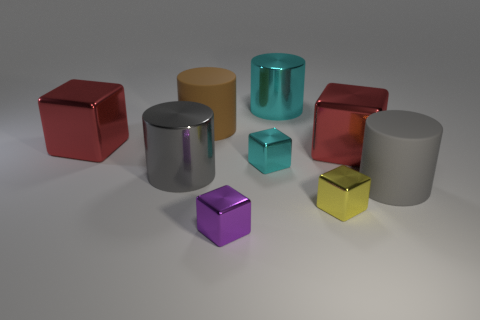Subtract all red cubes. How many gray cylinders are left? 2 Subtract 2 blocks. How many blocks are left? 3 Subtract all yellow blocks. How many blocks are left? 4 Subtract all tiny purple metal cubes. How many cubes are left? 4 Subtract all yellow cylinders. Subtract all blue blocks. How many cylinders are left? 4 Subtract all cylinders. How many objects are left? 5 Add 3 gray metal cylinders. How many gray metal cylinders are left? 4 Add 2 large red balls. How many large red balls exist? 2 Subtract 1 purple blocks. How many objects are left? 8 Subtract all tiny red cylinders. Subtract all red objects. How many objects are left? 7 